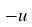<formula> <loc_0><loc_0><loc_500><loc_500>- u</formula> 